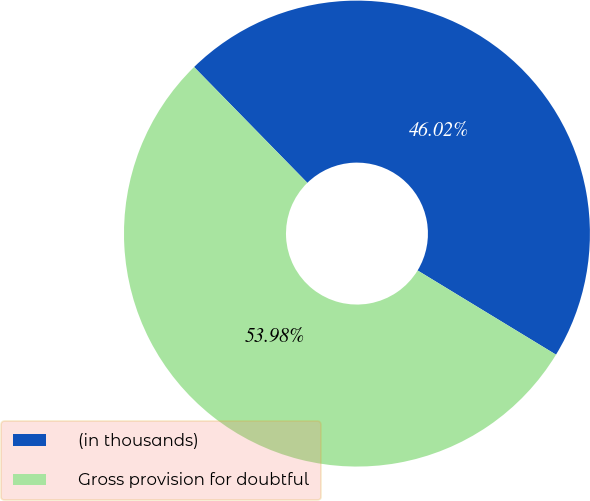<chart> <loc_0><loc_0><loc_500><loc_500><pie_chart><fcel>(in thousands)<fcel>Gross provision for doubtful<nl><fcel>46.02%<fcel>53.98%<nl></chart> 